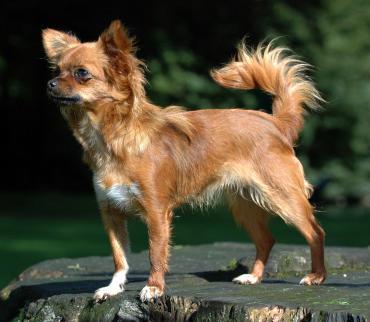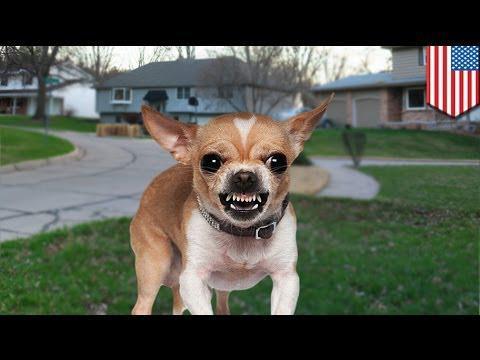The first image is the image on the left, the second image is the image on the right. Considering the images on both sides, is "A chihuahua with its body turned toward the camera is baring its fangs." valid? Answer yes or no. Yes. The first image is the image on the left, the second image is the image on the right. Analyze the images presented: Is the assertion "The right image contains no more than one dog." valid? Answer yes or no. Yes. 